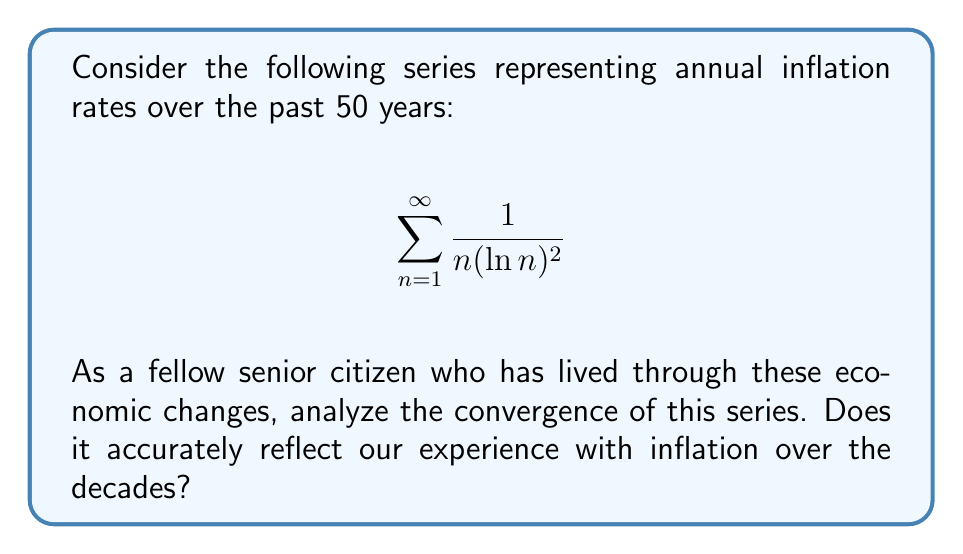Can you solve this math problem? Let's analyze this series step-by-step:

1) First, we recognize this as a p-series with an additional logarithmic term. The general form is:

   $$\sum_{n=1}^{\infty} \frac{1}{n^p (\ln n)^q}$$

   where in our case, $p = 1$ and $q = 2$.

2) For series of this form, we can use the integral test. The corresponding integral is:

   $$\int_{2}^{\infty} \frac{1}{x(\ln x)^2} dx$$

   (We start from 2 to avoid issues with $\ln 1 = 0$)

3) To evaluate this integral, we can use the substitution $u = \ln x$:
   
   $x = e^u$
   $dx = e^u du$

4) Substituting:

   $$\int_{2}^{\infty} \frac{1}{x(\ln x)^2} dx = \int_{\ln 2}^{\infty} \frac{1}{e^u u^2} e^u du = \int_{\ln 2}^{\infty} \frac{1}{u^2} du$$

5) Evaluating this integral:

   $$\left[-\frac{1}{u}\right]_{\ln 2}^{\infty} = 0 - \left(-\frac{1}{\ln 2}\right) = \frac{1}{\ln 2}$$

6) Since this integral converges to a finite value, by the integral test, our original series also converges.

From an economic perspective, this convergence suggests that while inflation rates may fluctuate, they tend to stabilize over time, which aligns with our experience as seniors who have lived through various economic cycles.
Answer: The series converges. 